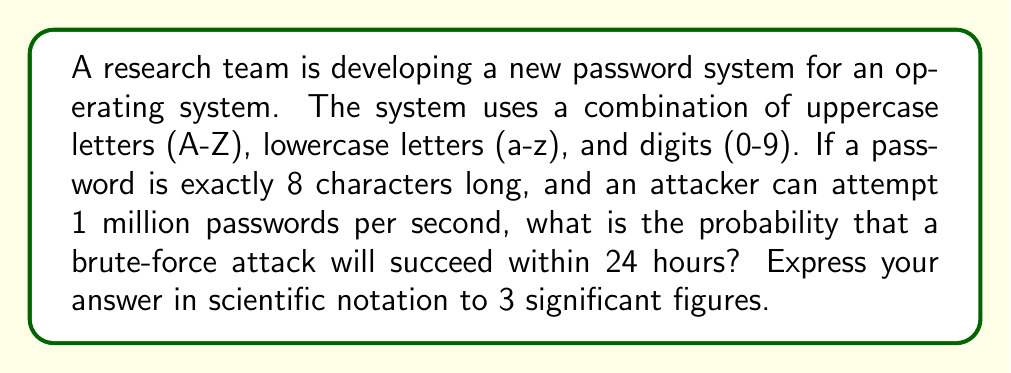Solve this math problem. To solve this problem, we need to follow these steps:

1. Calculate the total number of possible passwords:
   - Number of possible characters: 26 (uppercase) + 26 (lowercase) + 10 (digits) = 62
   - Password length: 8
   - Total possibilities: $62^8$

2. Calculate the number of attempts possible in 24 hours:
   - Attempts per second: 1,000,000
   - Seconds in 24 hours: 24 * 60 * 60 = 86,400
   - Total attempts: 1,000,000 * 86,400

3. Calculate the probability of success:
   - Probability = (Number of attempts) / (Total possibilities)

Let's go through each step:

1. Total possible passwords:
   $$N = 62^8 = 218,340,105,584,896$$

2. Number of attempts in 24 hours:
   $$A = 1,000,000 * 86,400 = 86,400,000,000$$

3. Probability of success:
   $$P = \frac{A}{N} = \frac{86,400,000,000}{218,340,105,584,896}$$

   $$P = 0.000395711...$$

Converting to scientific notation with 3 significant figures:
   $$P \approx 3.96 \times 10^{-4}$$
Answer: $3.96 \times 10^{-4}$ 